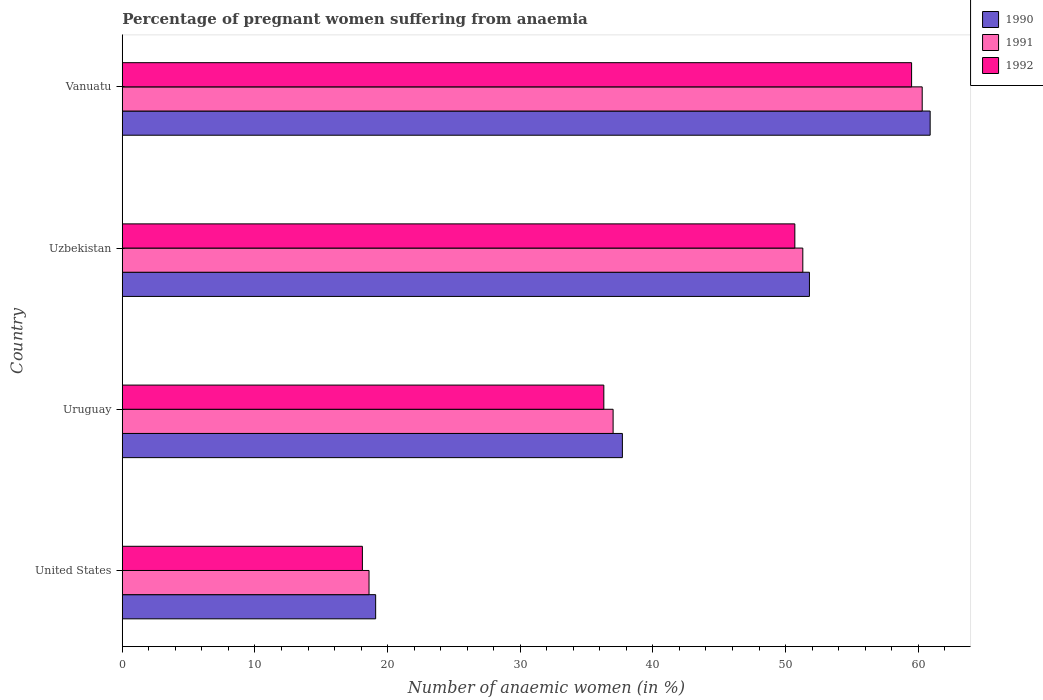How many different coloured bars are there?
Your answer should be very brief. 3. How many groups of bars are there?
Keep it short and to the point. 4. What is the label of the 4th group of bars from the top?
Keep it short and to the point. United States. What is the number of anaemic women in 1992 in Uzbekistan?
Your answer should be very brief. 50.7. Across all countries, what is the maximum number of anaemic women in 1992?
Ensure brevity in your answer.  59.5. Across all countries, what is the minimum number of anaemic women in 1990?
Offer a very short reply. 19.1. In which country was the number of anaemic women in 1991 maximum?
Your answer should be compact. Vanuatu. What is the total number of anaemic women in 1990 in the graph?
Offer a very short reply. 169.5. What is the difference between the number of anaemic women in 1992 in Uruguay and that in Uzbekistan?
Offer a terse response. -14.4. What is the difference between the number of anaemic women in 1990 in Uzbekistan and the number of anaemic women in 1992 in United States?
Your answer should be very brief. 33.7. What is the average number of anaemic women in 1990 per country?
Your answer should be very brief. 42.38. What is the difference between the number of anaemic women in 1991 and number of anaemic women in 1990 in Vanuatu?
Keep it short and to the point. -0.6. What is the ratio of the number of anaemic women in 1991 in United States to that in Uzbekistan?
Provide a succinct answer. 0.36. Is the difference between the number of anaemic women in 1991 in Uruguay and Uzbekistan greater than the difference between the number of anaemic women in 1990 in Uruguay and Uzbekistan?
Provide a succinct answer. No. What is the difference between the highest and the second highest number of anaemic women in 1990?
Give a very brief answer. 9.1. What is the difference between the highest and the lowest number of anaemic women in 1991?
Your answer should be very brief. 41.7. Is the sum of the number of anaemic women in 1992 in Uzbekistan and Vanuatu greater than the maximum number of anaemic women in 1991 across all countries?
Your response must be concise. Yes. What does the 2nd bar from the top in Uruguay represents?
Make the answer very short. 1991. What does the 1st bar from the bottom in Uruguay represents?
Offer a terse response. 1990. How many bars are there?
Give a very brief answer. 12. Are all the bars in the graph horizontal?
Ensure brevity in your answer.  Yes. What is the difference between two consecutive major ticks on the X-axis?
Your answer should be compact. 10. Does the graph contain any zero values?
Make the answer very short. No. How many legend labels are there?
Offer a very short reply. 3. How are the legend labels stacked?
Your answer should be compact. Vertical. What is the title of the graph?
Your response must be concise. Percentage of pregnant women suffering from anaemia. What is the label or title of the X-axis?
Give a very brief answer. Number of anaemic women (in %). What is the label or title of the Y-axis?
Provide a short and direct response. Country. What is the Number of anaemic women (in %) of 1991 in United States?
Provide a short and direct response. 18.6. What is the Number of anaemic women (in %) in 1992 in United States?
Your answer should be compact. 18.1. What is the Number of anaemic women (in %) in 1990 in Uruguay?
Keep it short and to the point. 37.7. What is the Number of anaemic women (in %) of 1992 in Uruguay?
Your answer should be very brief. 36.3. What is the Number of anaemic women (in %) in 1990 in Uzbekistan?
Provide a short and direct response. 51.8. What is the Number of anaemic women (in %) of 1991 in Uzbekistan?
Your answer should be compact. 51.3. What is the Number of anaemic women (in %) in 1992 in Uzbekistan?
Give a very brief answer. 50.7. What is the Number of anaemic women (in %) of 1990 in Vanuatu?
Provide a short and direct response. 60.9. What is the Number of anaemic women (in %) in 1991 in Vanuatu?
Make the answer very short. 60.3. What is the Number of anaemic women (in %) of 1992 in Vanuatu?
Offer a very short reply. 59.5. Across all countries, what is the maximum Number of anaemic women (in %) in 1990?
Offer a terse response. 60.9. Across all countries, what is the maximum Number of anaemic women (in %) of 1991?
Give a very brief answer. 60.3. Across all countries, what is the maximum Number of anaemic women (in %) in 1992?
Your answer should be compact. 59.5. Across all countries, what is the minimum Number of anaemic women (in %) in 1990?
Offer a very short reply. 19.1. Across all countries, what is the minimum Number of anaemic women (in %) of 1991?
Make the answer very short. 18.6. Across all countries, what is the minimum Number of anaemic women (in %) of 1992?
Provide a succinct answer. 18.1. What is the total Number of anaemic women (in %) in 1990 in the graph?
Offer a very short reply. 169.5. What is the total Number of anaemic women (in %) of 1991 in the graph?
Keep it short and to the point. 167.2. What is the total Number of anaemic women (in %) in 1992 in the graph?
Offer a terse response. 164.6. What is the difference between the Number of anaemic women (in %) of 1990 in United States and that in Uruguay?
Offer a terse response. -18.6. What is the difference between the Number of anaemic women (in %) of 1991 in United States and that in Uruguay?
Provide a succinct answer. -18.4. What is the difference between the Number of anaemic women (in %) of 1992 in United States and that in Uruguay?
Give a very brief answer. -18.2. What is the difference between the Number of anaemic women (in %) of 1990 in United States and that in Uzbekistan?
Your answer should be very brief. -32.7. What is the difference between the Number of anaemic women (in %) of 1991 in United States and that in Uzbekistan?
Give a very brief answer. -32.7. What is the difference between the Number of anaemic women (in %) of 1992 in United States and that in Uzbekistan?
Provide a short and direct response. -32.6. What is the difference between the Number of anaemic women (in %) of 1990 in United States and that in Vanuatu?
Make the answer very short. -41.8. What is the difference between the Number of anaemic women (in %) in 1991 in United States and that in Vanuatu?
Offer a terse response. -41.7. What is the difference between the Number of anaemic women (in %) in 1992 in United States and that in Vanuatu?
Ensure brevity in your answer.  -41.4. What is the difference between the Number of anaemic women (in %) of 1990 in Uruguay and that in Uzbekistan?
Give a very brief answer. -14.1. What is the difference between the Number of anaemic women (in %) of 1991 in Uruguay and that in Uzbekistan?
Provide a succinct answer. -14.3. What is the difference between the Number of anaemic women (in %) in 1992 in Uruguay and that in Uzbekistan?
Your answer should be very brief. -14.4. What is the difference between the Number of anaemic women (in %) of 1990 in Uruguay and that in Vanuatu?
Ensure brevity in your answer.  -23.2. What is the difference between the Number of anaemic women (in %) of 1991 in Uruguay and that in Vanuatu?
Your answer should be very brief. -23.3. What is the difference between the Number of anaemic women (in %) of 1992 in Uruguay and that in Vanuatu?
Your answer should be compact. -23.2. What is the difference between the Number of anaemic women (in %) in 1992 in Uzbekistan and that in Vanuatu?
Provide a succinct answer. -8.8. What is the difference between the Number of anaemic women (in %) in 1990 in United States and the Number of anaemic women (in %) in 1991 in Uruguay?
Offer a very short reply. -17.9. What is the difference between the Number of anaemic women (in %) in 1990 in United States and the Number of anaemic women (in %) in 1992 in Uruguay?
Keep it short and to the point. -17.2. What is the difference between the Number of anaemic women (in %) of 1991 in United States and the Number of anaemic women (in %) of 1992 in Uruguay?
Your answer should be very brief. -17.7. What is the difference between the Number of anaemic women (in %) in 1990 in United States and the Number of anaemic women (in %) in 1991 in Uzbekistan?
Your answer should be very brief. -32.2. What is the difference between the Number of anaemic women (in %) in 1990 in United States and the Number of anaemic women (in %) in 1992 in Uzbekistan?
Make the answer very short. -31.6. What is the difference between the Number of anaemic women (in %) of 1991 in United States and the Number of anaemic women (in %) of 1992 in Uzbekistan?
Your answer should be compact. -32.1. What is the difference between the Number of anaemic women (in %) in 1990 in United States and the Number of anaemic women (in %) in 1991 in Vanuatu?
Provide a short and direct response. -41.2. What is the difference between the Number of anaemic women (in %) of 1990 in United States and the Number of anaemic women (in %) of 1992 in Vanuatu?
Your answer should be very brief. -40.4. What is the difference between the Number of anaemic women (in %) in 1991 in United States and the Number of anaemic women (in %) in 1992 in Vanuatu?
Provide a short and direct response. -40.9. What is the difference between the Number of anaemic women (in %) of 1990 in Uruguay and the Number of anaemic women (in %) of 1991 in Uzbekistan?
Give a very brief answer. -13.6. What is the difference between the Number of anaemic women (in %) of 1991 in Uruguay and the Number of anaemic women (in %) of 1992 in Uzbekistan?
Provide a short and direct response. -13.7. What is the difference between the Number of anaemic women (in %) of 1990 in Uruguay and the Number of anaemic women (in %) of 1991 in Vanuatu?
Your answer should be very brief. -22.6. What is the difference between the Number of anaemic women (in %) in 1990 in Uruguay and the Number of anaemic women (in %) in 1992 in Vanuatu?
Your response must be concise. -21.8. What is the difference between the Number of anaemic women (in %) of 1991 in Uruguay and the Number of anaemic women (in %) of 1992 in Vanuatu?
Provide a short and direct response. -22.5. What is the difference between the Number of anaemic women (in %) in 1990 in Uzbekistan and the Number of anaemic women (in %) in 1991 in Vanuatu?
Offer a very short reply. -8.5. What is the difference between the Number of anaemic women (in %) in 1990 in Uzbekistan and the Number of anaemic women (in %) in 1992 in Vanuatu?
Ensure brevity in your answer.  -7.7. What is the average Number of anaemic women (in %) in 1990 per country?
Give a very brief answer. 42.38. What is the average Number of anaemic women (in %) of 1991 per country?
Ensure brevity in your answer.  41.8. What is the average Number of anaemic women (in %) of 1992 per country?
Keep it short and to the point. 41.15. What is the difference between the Number of anaemic women (in %) in 1990 and Number of anaemic women (in %) in 1991 in United States?
Ensure brevity in your answer.  0.5. What is the difference between the Number of anaemic women (in %) in 1991 and Number of anaemic women (in %) in 1992 in Uruguay?
Provide a succinct answer. 0.7. What is the difference between the Number of anaemic women (in %) in 1990 and Number of anaemic women (in %) in 1991 in Uzbekistan?
Give a very brief answer. 0.5. What is the difference between the Number of anaemic women (in %) in 1991 and Number of anaemic women (in %) in 1992 in Uzbekistan?
Your answer should be very brief. 0.6. What is the difference between the Number of anaemic women (in %) of 1990 and Number of anaemic women (in %) of 1991 in Vanuatu?
Keep it short and to the point. 0.6. What is the difference between the Number of anaemic women (in %) of 1991 and Number of anaemic women (in %) of 1992 in Vanuatu?
Provide a short and direct response. 0.8. What is the ratio of the Number of anaemic women (in %) of 1990 in United States to that in Uruguay?
Offer a very short reply. 0.51. What is the ratio of the Number of anaemic women (in %) of 1991 in United States to that in Uruguay?
Give a very brief answer. 0.5. What is the ratio of the Number of anaemic women (in %) of 1992 in United States to that in Uruguay?
Make the answer very short. 0.5. What is the ratio of the Number of anaemic women (in %) of 1990 in United States to that in Uzbekistan?
Provide a succinct answer. 0.37. What is the ratio of the Number of anaemic women (in %) of 1991 in United States to that in Uzbekistan?
Provide a short and direct response. 0.36. What is the ratio of the Number of anaemic women (in %) in 1992 in United States to that in Uzbekistan?
Ensure brevity in your answer.  0.36. What is the ratio of the Number of anaemic women (in %) of 1990 in United States to that in Vanuatu?
Make the answer very short. 0.31. What is the ratio of the Number of anaemic women (in %) in 1991 in United States to that in Vanuatu?
Provide a succinct answer. 0.31. What is the ratio of the Number of anaemic women (in %) in 1992 in United States to that in Vanuatu?
Your answer should be compact. 0.3. What is the ratio of the Number of anaemic women (in %) of 1990 in Uruguay to that in Uzbekistan?
Offer a terse response. 0.73. What is the ratio of the Number of anaemic women (in %) of 1991 in Uruguay to that in Uzbekistan?
Offer a terse response. 0.72. What is the ratio of the Number of anaemic women (in %) of 1992 in Uruguay to that in Uzbekistan?
Keep it short and to the point. 0.72. What is the ratio of the Number of anaemic women (in %) in 1990 in Uruguay to that in Vanuatu?
Your response must be concise. 0.62. What is the ratio of the Number of anaemic women (in %) of 1991 in Uruguay to that in Vanuatu?
Ensure brevity in your answer.  0.61. What is the ratio of the Number of anaemic women (in %) in 1992 in Uruguay to that in Vanuatu?
Provide a succinct answer. 0.61. What is the ratio of the Number of anaemic women (in %) of 1990 in Uzbekistan to that in Vanuatu?
Offer a very short reply. 0.85. What is the ratio of the Number of anaemic women (in %) of 1991 in Uzbekistan to that in Vanuatu?
Make the answer very short. 0.85. What is the ratio of the Number of anaemic women (in %) of 1992 in Uzbekistan to that in Vanuatu?
Provide a short and direct response. 0.85. What is the difference between the highest and the second highest Number of anaemic women (in %) in 1991?
Your answer should be compact. 9. What is the difference between the highest and the second highest Number of anaemic women (in %) in 1992?
Your answer should be very brief. 8.8. What is the difference between the highest and the lowest Number of anaemic women (in %) in 1990?
Offer a terse response. 41.8. What is the difference between the highest and the lowest Number of anaemic women (in %) of 1991?
Give a very brief answer. 41.7. What is the difference between the highest and the lowest Number of anaemic women (in %) in 1992?
Provide a short and direct response. 41.4. 